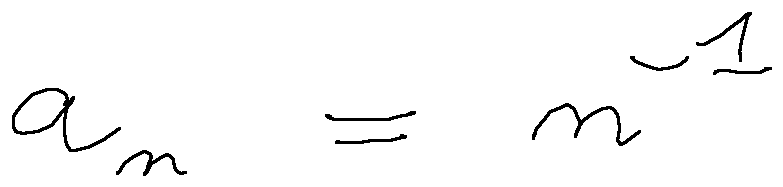Convert formula to latex. <formula><loc_0><loc_0><loc_500><loc_500>a _ { n } = n ^ { - 1 }</formula> 